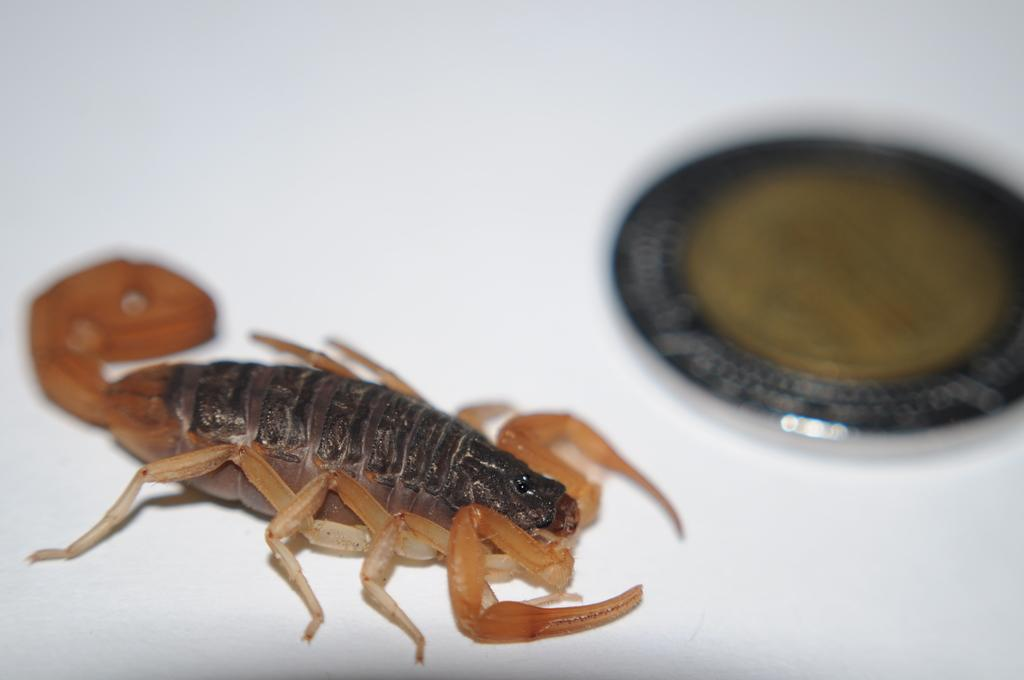What type of animal is in the image? There is a scorpion in the image. What other object can be seen in the image? There is a coin in the image. Can you describe the third object in the image? There is a white object in the image. What type of island can be seen in the image? There is no island present in the image. Can you tell me how many windows are visible in the image? There are no windows present in the image. 